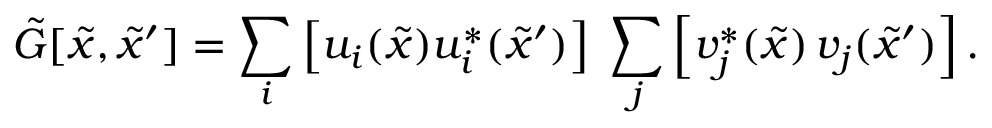Convert formula to latex. <formula><loc_0><loc_0><loc_500><loc_500>{ \tilde { G } } [ { \tilde { x } } , { \tilde { x } ^ { \prime } } ] = \sum _ { i } \left [ u _ { i } ( { \tilde { x } } ) u _ { i } ^ { * } ( { \tilde { x } ^ { \prime } } ) \right ] \, \sum _ { j } \left [ v _ { j } ^ { * } ( { \tilde { x } } ) \, v _ { j } ( { \tilde { x } ^ { \prime } } ) \right ] .</formula> 